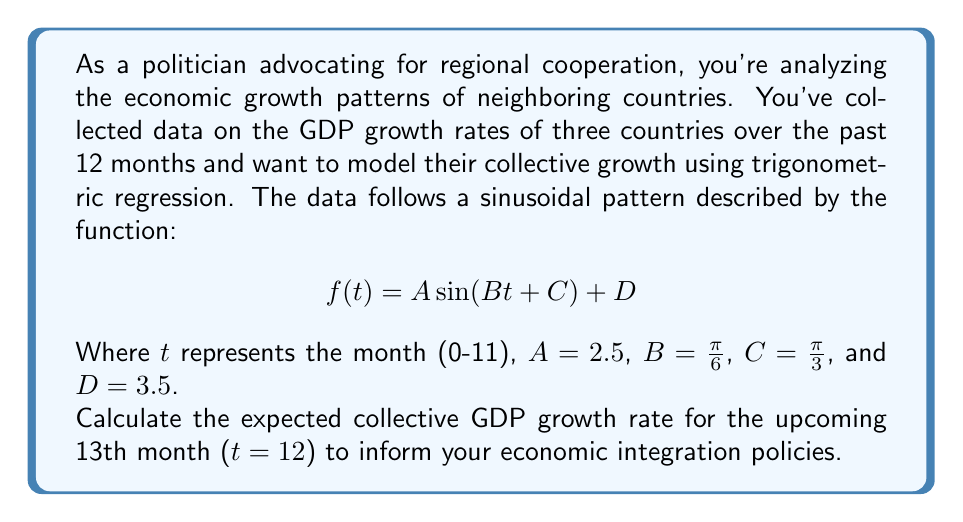Teach me how to tackle this problem. To solve this problem, we need to follow these steps:

1) We have the general form of the sinusoidal function:
   $$f(t) = A \sin(Bt + C) + D$$

2) We're given the values:
   $A = 2.5$, $B = \frac{\pi}{6}$, $C = \frac{\pi}{3}$, and $D = 3.5$

3) Substituting these values into the function:
   $$f(t) = 2.5 \sin(\frac{\pi}{6}t + \frac{\pi}{3}) + 3.5$$

4) We need to calculate $f(12)$ as we're interested in the 13th month (t = 12):
   $$f(12) = 2.5 \sin(\frac{\pi}{6} \cdot 12 + \frac{\pi}{3}) + 3.5$$

5) Simplify the argument of sine:
   $$f(12) = 2.5 \sin(2\pi + \frac{\pi}{3}) + 3.5$$

6) Recall that $\sin(2\pi + \theta) = \sin(\theta)$ for any angle $\theta$:
   $$f(12) = 2.5 \sin(\frac{\pi}{3}) + 3.5$$

7) $\sin(\frac{\pi}{3}) = \frac{\sqrt{3}}{2}$

8) Substituting this value:
   $$f(12) = 2.5 \cdot \frac{\sqrt{3}}{2} + 3.5$$

9) Simplify:
   $$f(12) = \frac{5\sqrt{3}}{4} + 3.5 \approx 5.66$$

Therefore, the expected collective GDP growth rate for the 13th month is approximately 5.66%.
Answer: $5.66\%$ 